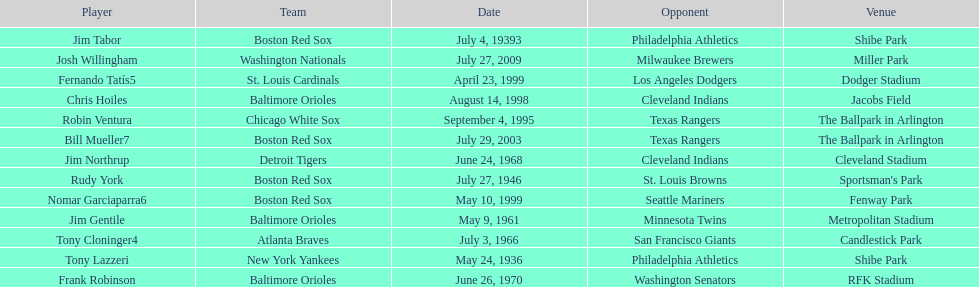On what date did the detroit tigers play the cleveland indians? June 24, 1968. 